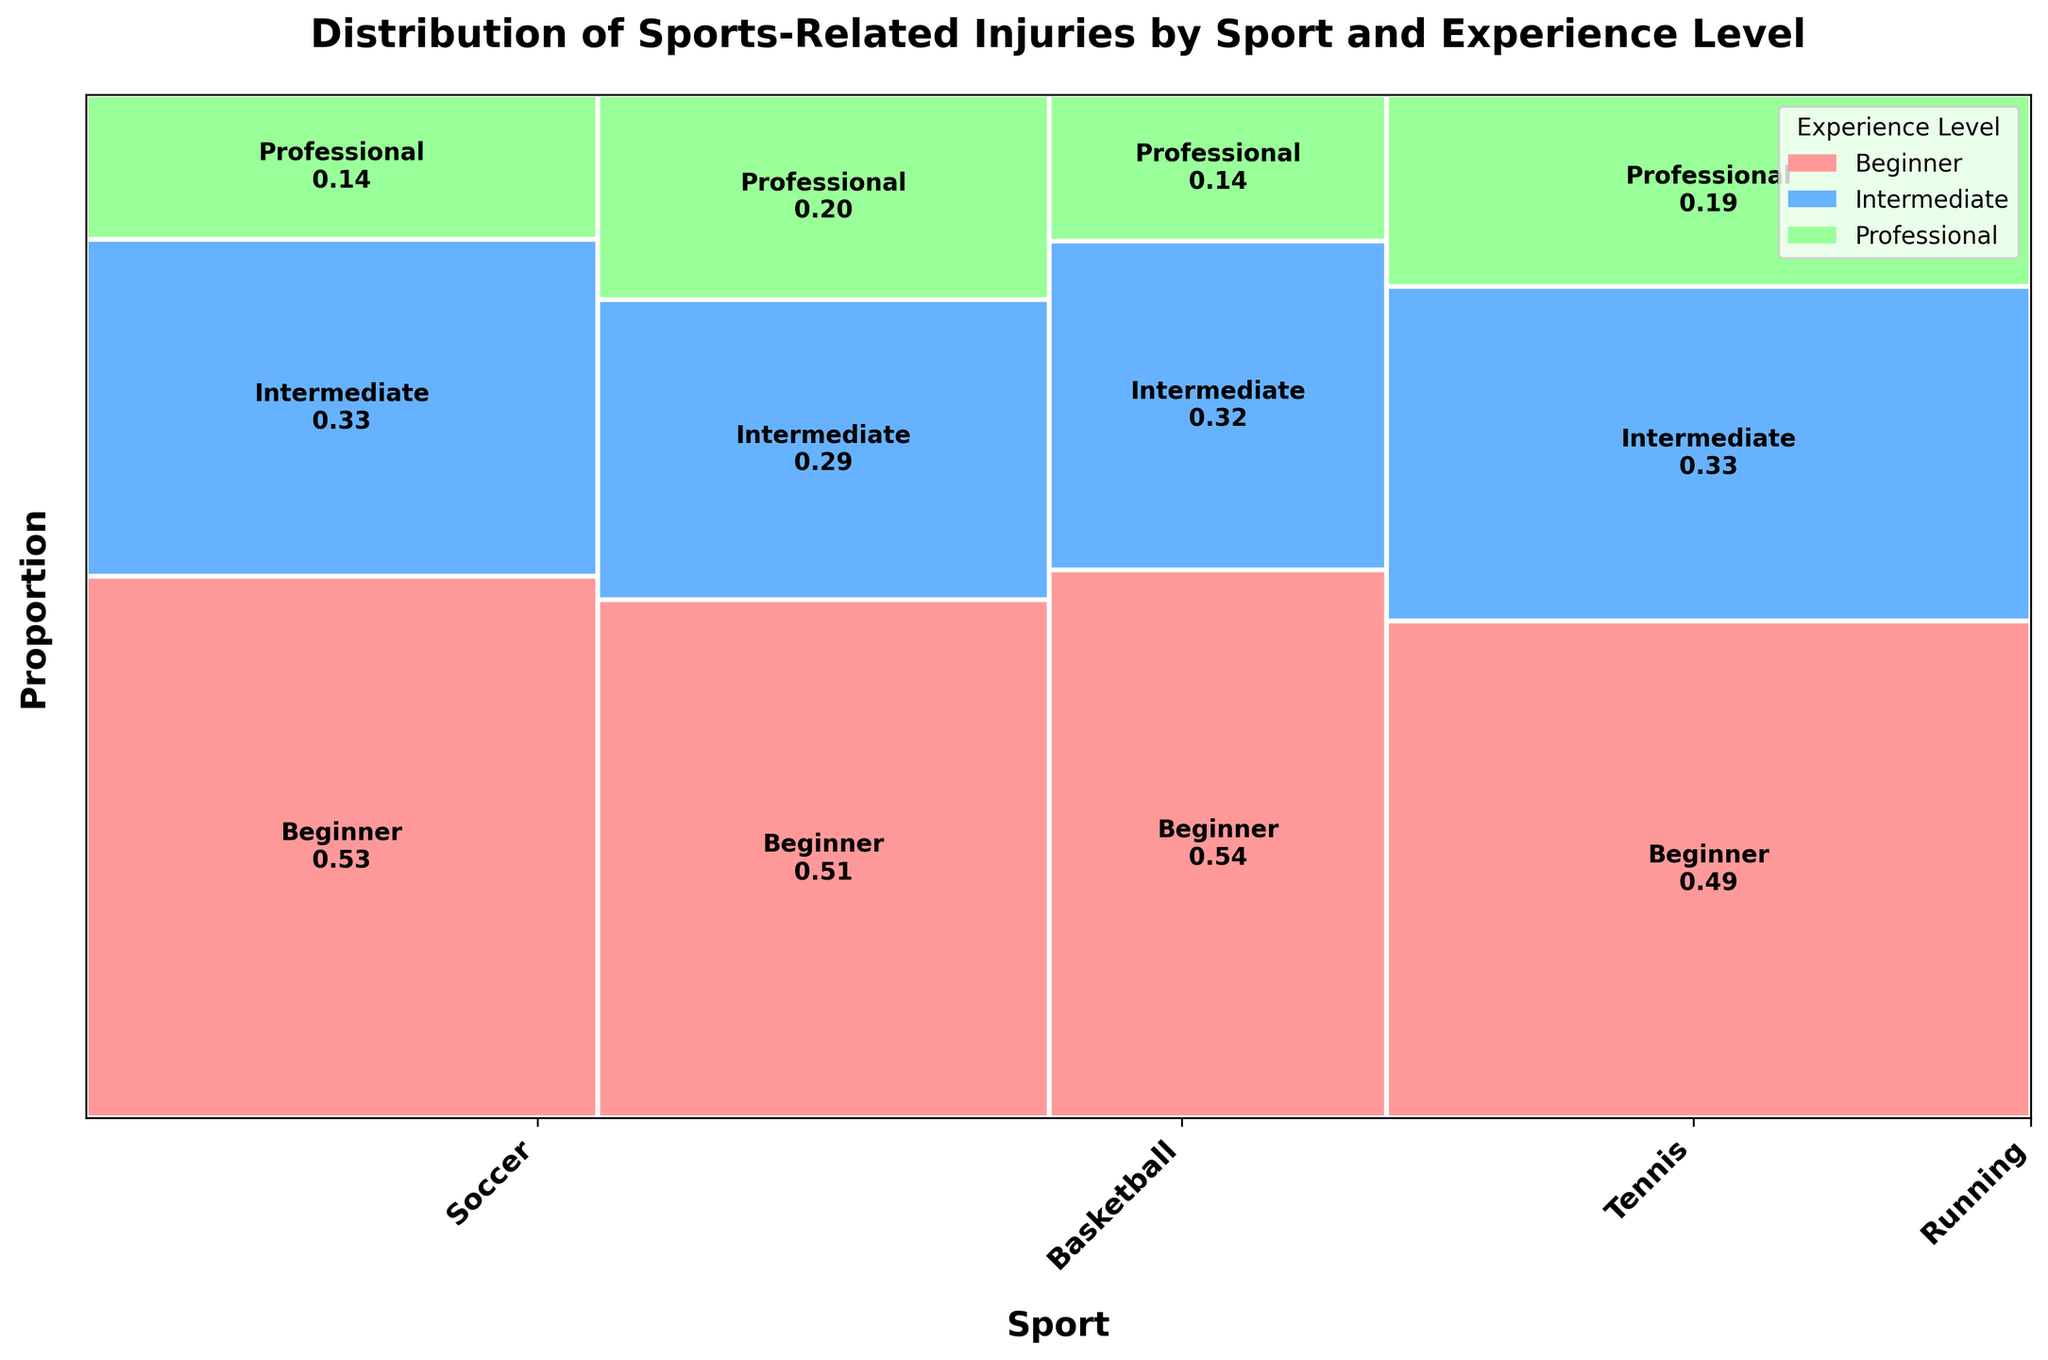What's the title of the figure? The title is usually displayed at the top of the figure. In this case, the title reads: "Distribution of Sports-Related Injuries by Sport and Experience Level".
Answer: Distribution of Sports-Related Injuries by Sport and Experience Level Which sport has the highest proportion of injuries? The width of each sport's section in the Mosaic Plot represents the proportion of injuries. The widest section corresponds to Running.
Answer: Running What is the most common injury type for Beginner athletes? Look for the largest proportion within the Beginner section across all sports. For Soccer, it is Sprain, for Basketball, it is Sprain, for Tennis, it is Tennis Elbow, and for Running, it is Shin Splints. The highest proportion here is Shin Splints in Running.
Answer: Shin Splints What colors are used to represent different experience levels? The plot uses distinct colors for different experience levels: red for Beginner, blue for Intermediate, and green for Professional.
Answer: Red, Blue, Green Which experience level has the smallest representation in Tennis? By comparing the heights of the sections within the Tennis category: Beginner has the largest section, followed by Intermediate, and the smallest is Professional.
Answer: Professional Which sport has the smallest proportion of injuries among Professional athletes? The height of the Professional section across sports should be compared. The smallest height is for Tennis.
Answer: Tennis Considering Professional athletes, which sport has the highest risk of Stress Fracture? Professional-level injuries include Tennis and Running for Stress Fracture. Compare the respective areas: Running has a larger proportion.
Answer: Running How do injuries for Intermediate athletes compare between Soccer and Basketball? The plot shows two heights for the Intermediate sections: Soccer (slightly more than Basketball). Soccer’s injury is Fracture while Basketball's is Tendinitis. Soccer's portion is larger than Basketball's.
Answer: Soccer has more injuries What is the proportion of injuries for Intermediate athletes in Running? Locate the Intermediate section within the Running category and note the proportion value displayed on the plot. The section shows a value of 0.35.
Answer: 0.35 Which experience level has the least injuries overall? By summing the lengths of each experience level across all sports: Professional has the smallest total accumulation.
Answer: Professional 